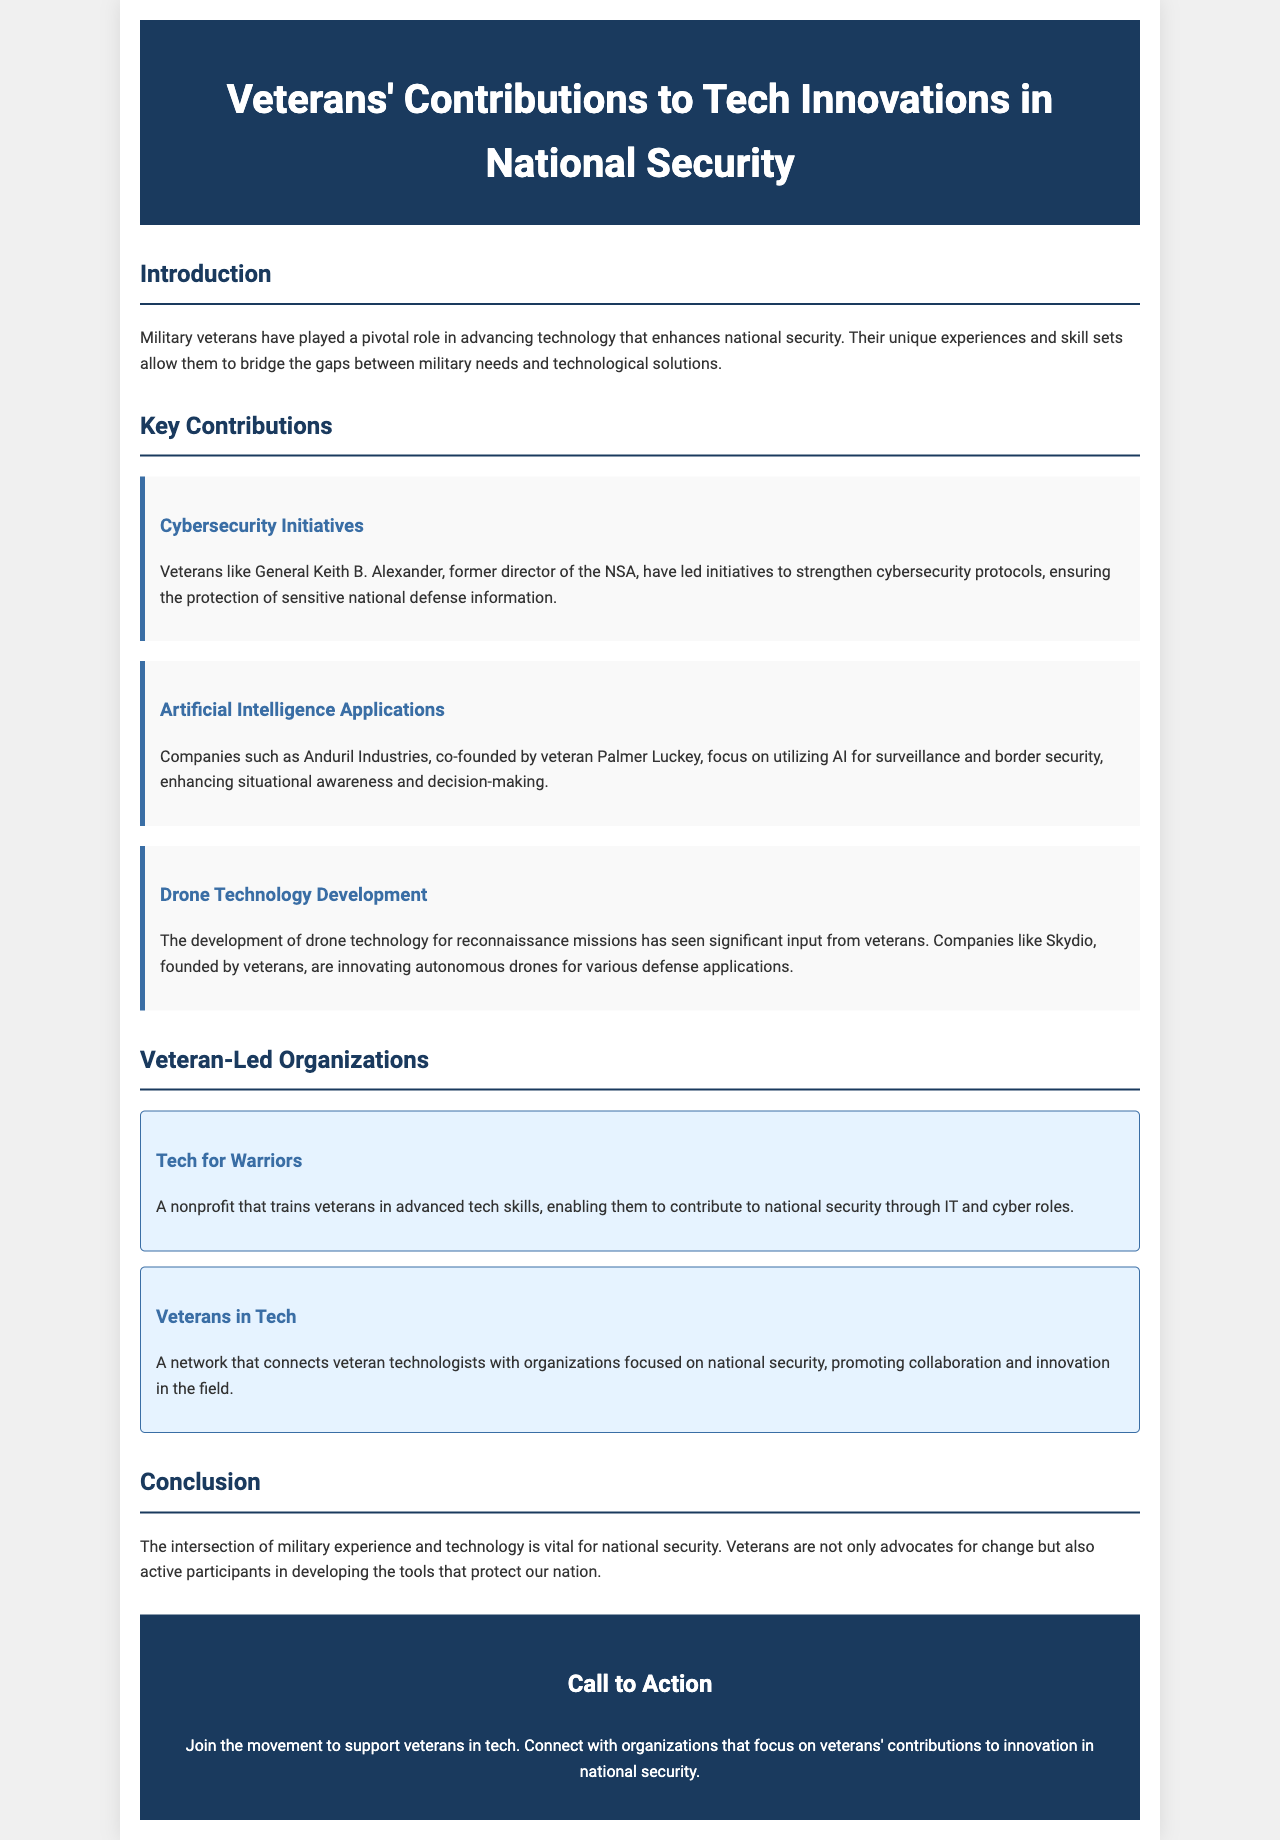What is the title of the brochure? The title appears in the header section of the document, which states "Veterans' Contributions to Tech Innovations in National Security."
Answer: Veterans' Contributions to Tech Innovations in National Security Who is a veteran mentioned in cybersecurity initiatives? The document mentions General Keith B. Alexander as a veteran leading cybersecurity initiatives.
Answer: General Keith B. Alexander Which company was co-founded by a veteran focusing on AI? The text specifies Anduril Industries, co-founded by veteran Palmer Luckey, as a company working on AI applications.
Answer: Anduril Industries What is the primary focus of Tech for Warriors? The brochure describes Tech for Warriors as a nonprofit that trains veterans in advanced tech skills.
Answer: Training veterans in advanced tech skills What technology is associated with Skydio? The document mentions that Skydio is innovating autonomous drones for defense applications.
Answer: Autonomous drones How many veteran-led organizations are listed in the brochure? There are two organizations mentioned under the section "Veteran-Led Organizations."
Answer: 2 What is the significance of veterans in national security according to the conclusion? The conclusion states that veterans are essential as both advocates for change and participants in technology development for national security.
Answer: Advocates for change and participants in technology development What organization promotes collaboration between veteran technologists and national security? The document identifies Veterans in Tech as the organization that connects veteran technologists with national security-focused organizations.
Answer: Veterans in Tech 